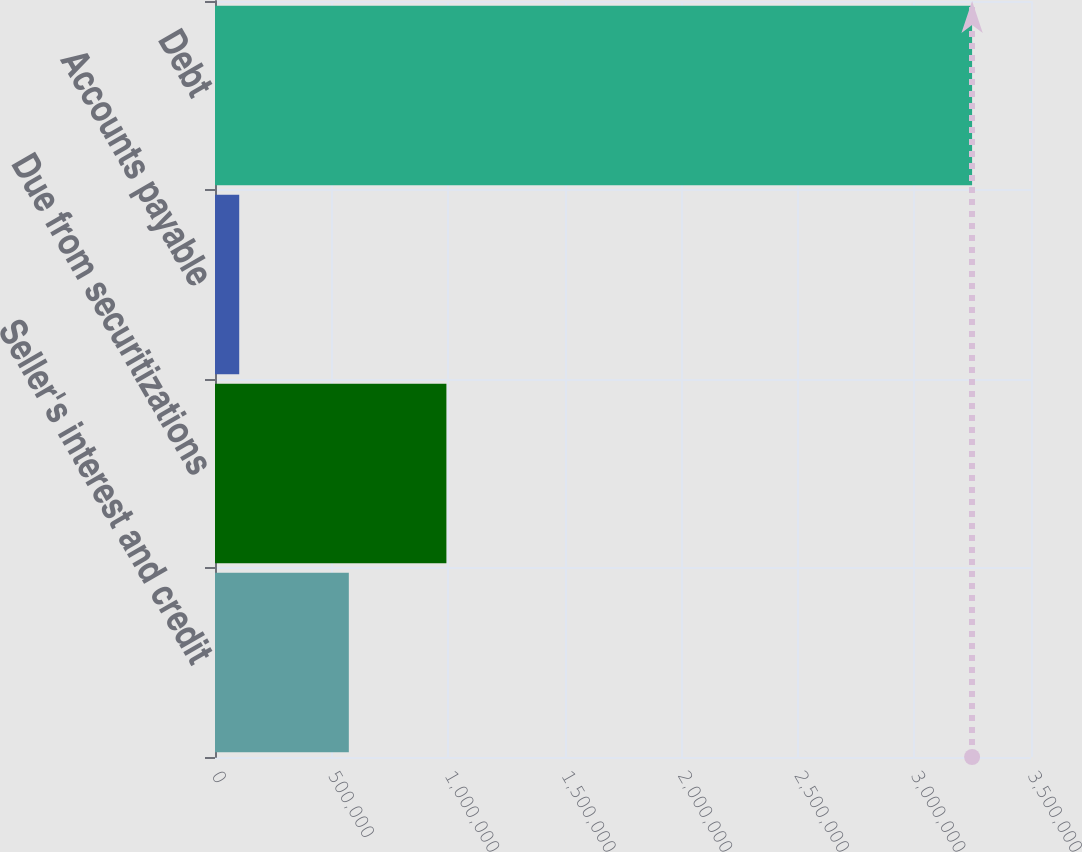Convert chart to OTSL. <chart><loc_0><loc_0><loc_500><loc_500><bar_chart><fcel>Seller's interest and credit<fcel>Due from securitizations<fcel>Accounts payable<fcel>Debt<nl><fcel>574004<fcel>992523<fcel>103891<fcel>3.24735e+06<nl></chart> 